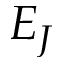Convert formula to latex. <formula><loc_0><loc_0><loc_500><loc_500>E _ { J }</formula> 